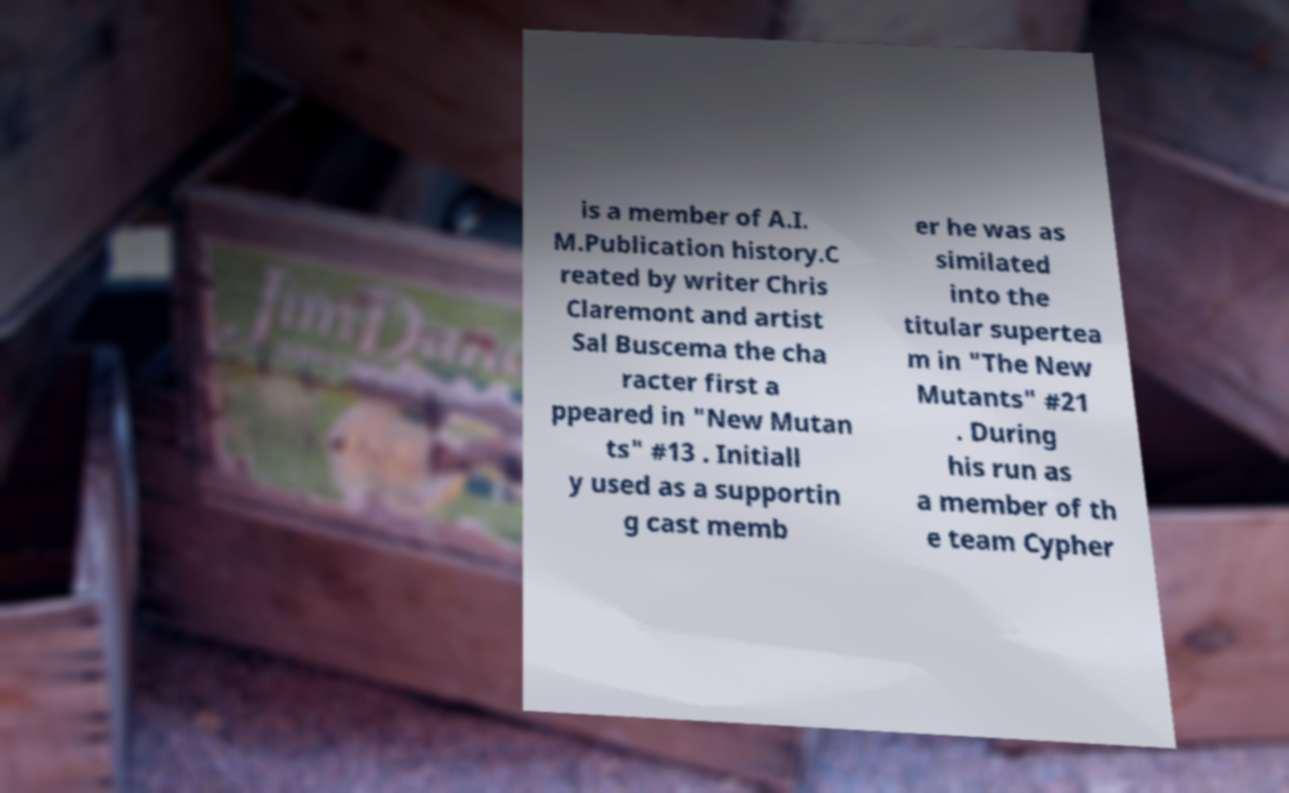For documentation purposes, I need the text within this image transcribed. Could you provide that? is a member of A.I. M.Publication history.C reated by writer Chris Claremont and artist Sal Buscema the cha racter first a ppeared in "New Mutan ts" #13 . Initiall y used as a supportin g cast memb er he was as similated into the titular supertea m in "The New Mutants" #21 . During his run as a member of th e team Cypher 